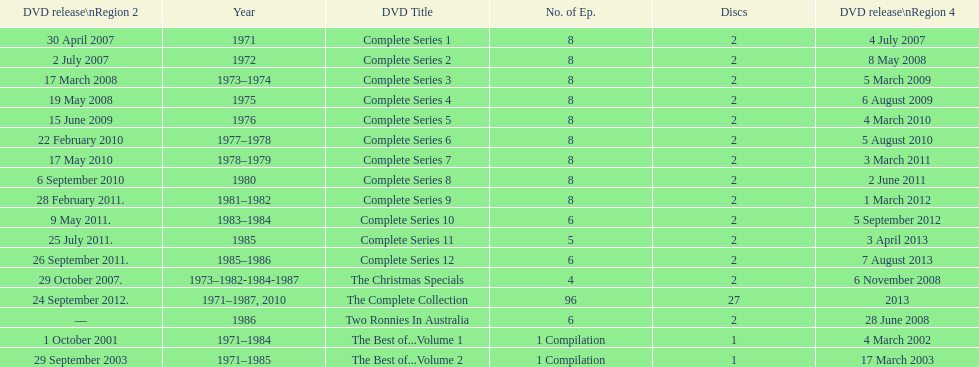What comes immediately after complete series 11? Complete Series 12. Could you parse the entire table? {'header': ['DVD release\\nRegion 2', 'Year', 'DVD Title', 'No. of Ep.', 'Discs', 'DVD release\\nRegion 4'], 'rows': [['30 April 2007', '1971', 'Complete Series 1', '8', '2', '4 July 2007'], ['2 July 2007', '1972', 'Complete Series 2', '8', '2', '8 May 2008'], ['17 March 2008', '1973–1974', 'Complete Series 3', '8', '2', '5 March 2009'], ['19 May 2008', '1975', 'Complete Series 4', '8', '2', '6 August 2009'], ['15 June 2009', '1976', 'Complete Series 5', '8', '2', '4 March 2010'], ['22 February 2010', '1977–1978', 'Complete Series 6', '8', '2', '5 August 2010'], ['17 May 2010', '1978–1979', 'Complete Series 7', '8', '2', '3 March 2011'], ['6 September 2010', '1980', 'Complete Series 8', '8', '2', '2 June 2011'], ['28 February 2011.', '1981–1982', 'Complete Series 9', '8', '2', '1 March 2012'], ['9 May 2011.', '1983–1984', 'Complete Series 10', '6', '2', '5 September 2012'], ['25 July 2011.', '1985', 'Complete Series 11', '5', '2', '3 April 2013'], ['26 September 2011.', '1985–1986', 'Complete Series 12', '6', '2', '7 August 2013'], ['29 October 2007.', '1973–1982-1984-1987', 'The Christmas Specials', '4', '2', '6 November 2008'], ['24 September 2012.', '1971–1987, 2010', 'The Complete Collection', '96', '27', '2013'], ['—', '1986', 'Two Ronnies In Australia', '6', '2', '28 June 2008'], ['1 October 2001', '1971–1984', 'The Best of...Volume 1', '1 Compilation', '1', '4 March 2002'], ['29 September 2003', '1971–1985', 'The Best of...Volume 2', '1 Compilation', '1', '17 March 2003']]} 